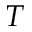Convert formula to latex. <formula><loc_0><loc_0><loc_500><loc_500>T</formula> 